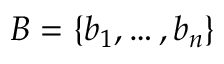<formula> <loc_0><loc_0><loc_500><loc_500>B = \{ b _ { 1 } , \dots , b _ { n } \}</formula> 